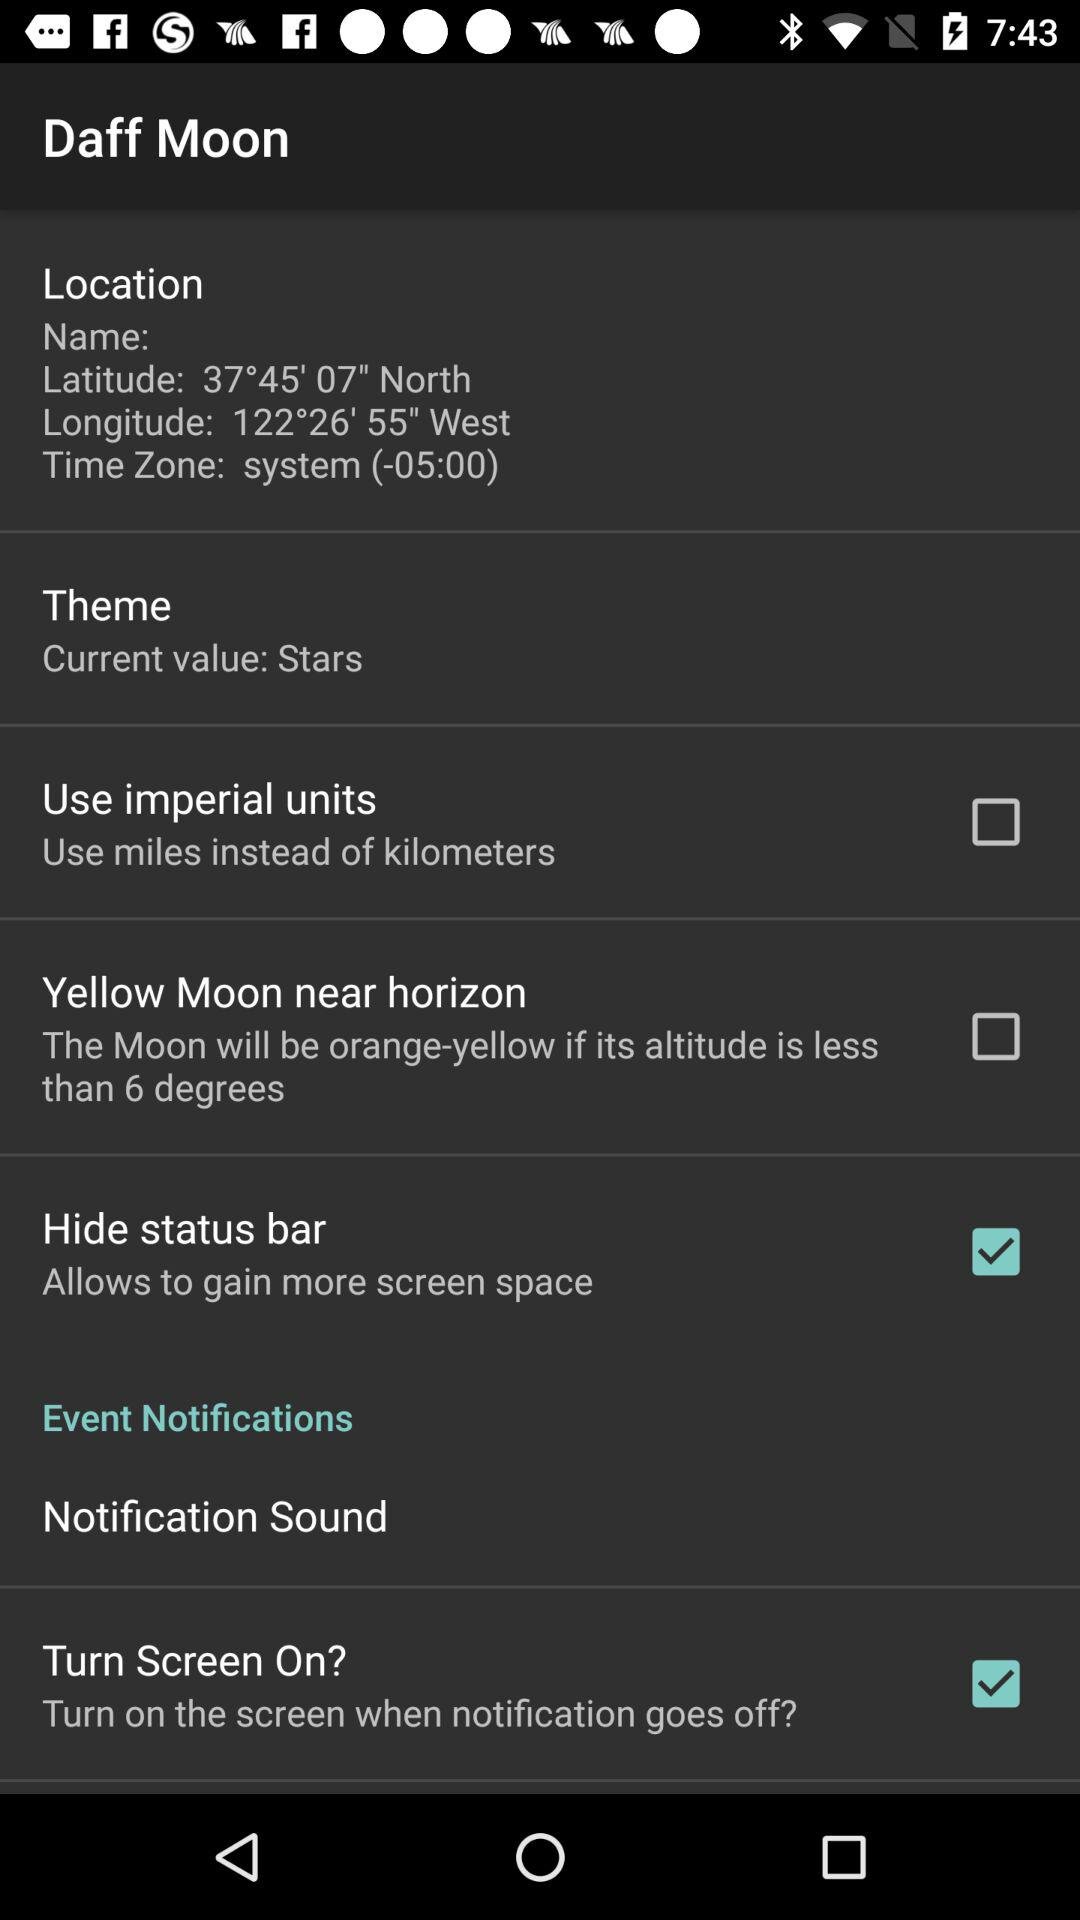What is the status of the "Use imperial units"? The status is "off". 